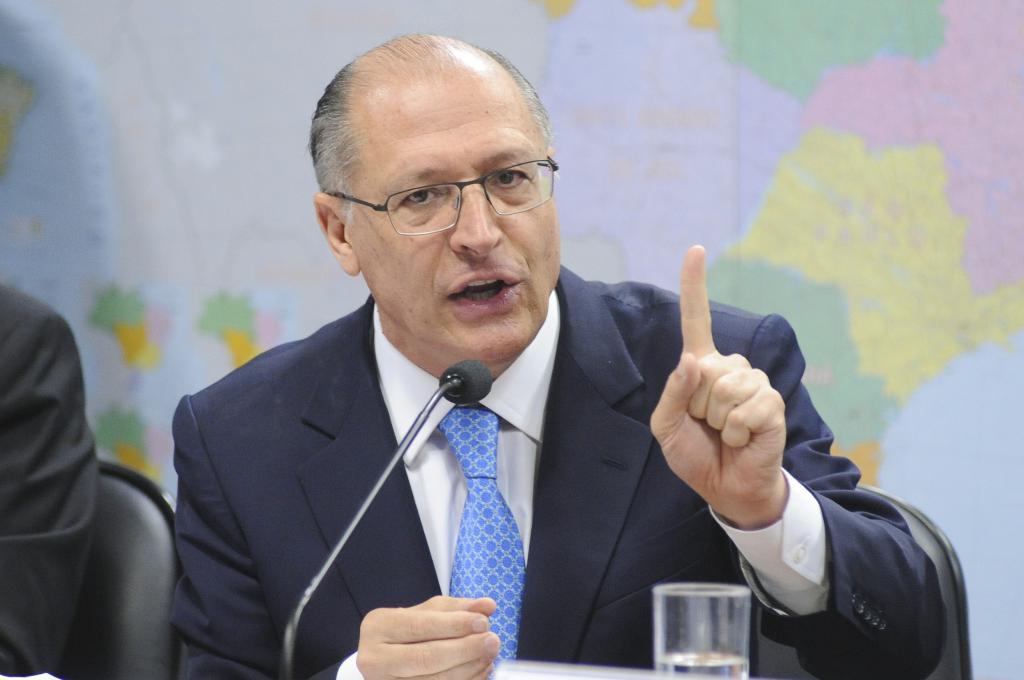How would you summarize this image in a sentence or two? In the center of the image we can see a man sitting. He is wearing a suit. At the bottom there is a mic and a glass. In the background we can see a map pasted on the wall. 